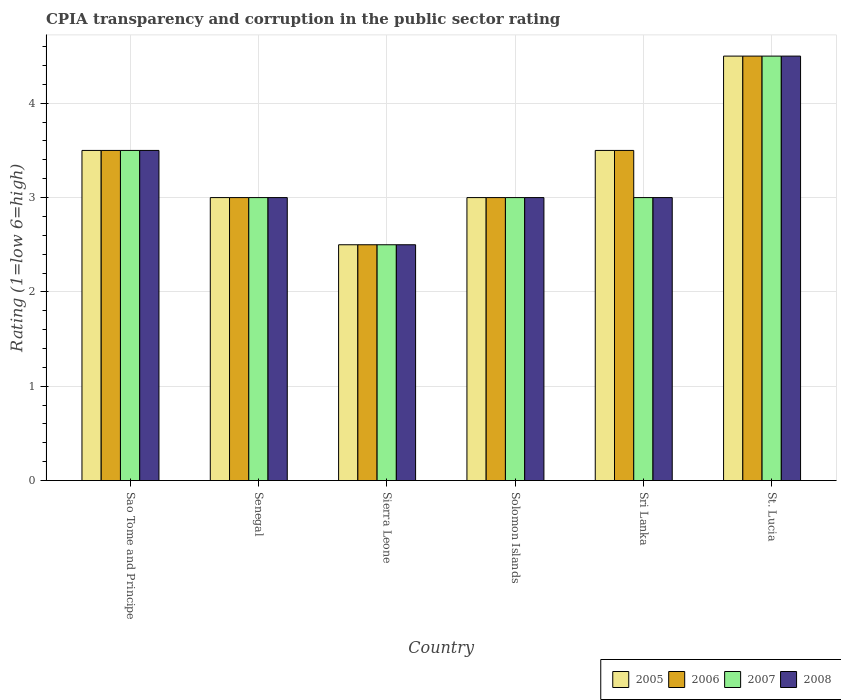How many groups of bars are there?
Offer a very short reply. 6. Are the number of bars per tick equal to the number of legend labels?
Make the answer very short. Yes. What is the label of the 3rd group of bars from the left?
Offer a very short reply. Sierra Leone. In how many cases, is the number of bars for a given country not equal to the number of legend labels?
Give a very brief answer. 0. What is the CPIA rating in 2008 in Sri Lanka?
Make the answer very short. 3. In which country was the CPIA rating in 2007 maximum?
Provide a short and direct response. St. Lucia. In which country was the CPIA rating in 2008 minimum?
Offer a terse response. Sierra Leone. What is the difference between the CPIA rating in 2007 in Sao Tome and Principe and that in St. Lucia?
Your response must be concise. -1. What is the difference between the CPIA rating in 2006 in Sierra Leone and the CPIA rating in 2008 in Solomon Islands?
Give a very brief answer. -0.5. What is the average CPIA rating in 2006 per country?
Your answer should be compact. 3.33. What is the difference between the CPIA rating of/in 2008 and CPIA rating of/in 2005 in Sao Tome and Principe?
Ensure brevity in your answer.  0. What is the ratio of the CPIA rating in 2005 in Sao Tome and Principe to that in St. Lucia?
Your answer should be very brief. 0.78. In how many countries, is the CPIA rating in 2008 greater than the average CPIA rating in 2008 taken over all countries?
Make the answer very short. 2. Is the sum of the CPIA rating in 2005 in Senegal and Sri Lanka greater than the maximum CPIA rating in 2007 across all countries?
Offer a terse response. Yes. What does the 1st bar from the left in Sao Tome and Principe represents?
Your answer should be very brief. 2005. What does the 1st bar from the right in Sierra Leone represents?
Your response must be concise. 2008. Is it the case that in every country, the sum of the CPIA rating in 2006 and CPIA rating in 2005 is greater than the CPIA rating in 2008?
Keep it short and to the point. Yes. How many bars are there?
Provide a short and direct response. 24. How many countries are there in the graph?
Make the answer very short. 6. What is the difference between two consecutive major ticks on the Y-axis?
Your answer should be very brief. 1. Are the values on the major ticks of Y-axis written in scientific E-notation?
Keep it short and to the point. No. Does the graph contain any zero values?
Ensure brevity in your answer.  No. Does the graph contain grids?
Your answer should be compact. Yes. Where does the legend appear in the graph?
Your answer should be compact. Bottom right. How many legend labels are there?
Keep it short and to the point. 4. What is the title of the graph?
Offer a terse response. CPIA transparency and corruption in the public sector rating. What is the label or title of the X-axis?
Provide a succinct answer. Country. What is the label or title of the Y-axis?
Make the answer very short. Rating (1=low 6=high). What is the Rating (1=low 6=high) in 2005 in Sao Tome and Principe?
Make the answer very short. 3.5. What is the Rating (1=low 6=high) in 2007 in Sao Tome and Principe?
Offer a terse response. 3.5. What is the Rating (1=low 6=high) of 2005 in Sierra Leone?
Offer a terse response. 2.5. What is the Rating (1=low 6=high) in 2006 in Sierra Leone?
Make the answer very short. 2.5. What is the Rating (1=low 6=high) of 2008 in Sierra Leone?
Keep it short and to the point. 2.5. What is the Rating (1=low 6=high) of 2005 in Solomon Islands?
Give a very brief answer. 3. What is the Rating (1=low 6=high) in 2006 in Solomon Islands?
Your answer should be very brief. 3. What is the Rating (1=low 6=high) of 2007 in Sri Lanka?
Your response must be concise. 3. What is the Rating (1=low 6=high) in 2005 in St. Lucia?
Keep it short and to the point. 4.5. What is the Rating (1=low 6=high) in 2006 in St. Lucia?
Give a very brief answer. 4.5. Across all countries, what is the maximum Rating (1=low 6=high) in 2005?
Offer a terse response. 4.5. Across all countries, what is the maximum Rating (1=low 6=high) of 2008?
Offer a terse response. 4.5. Across all countries, what is the minimum Rating (1=low 6=high) of 2005?
Provide a succinct answer. 2.5. Across all countries, what is the minimum Rating (1=low 6=high) in 2006?
Offer a very short reply. 2.5. Across all countries, what is the minimum Rating (1=low 6=high) in 2007?
Offer a terse response. 2.5. What is the total Rating (1=low 6=high) in 2005 in the graph?
Provide a short and direct response. 20. What is the total Rating (1=low 6=high) of 2007 in the graph?
Make the answer very short. 19.5. What is the difference between the Rating (1=low 6=high) in 2005 in Sao Tome and Principe and that in Senegal?
Ensure brevity in your answer.  0.5. What is the difference between the Rating (1=low 6=high) of 2006 in Sao Tome and Principe and that in Senegal?
Ensure brevity in your answer.  0.5. What is the difference between the Rating (1=low 6=high) in 2005 in Sao Tome and Principe and that in Sierra Leone?
Your answer should be compact. 1. What is the difference between the Rating (1=low 6=high) of 2008 in Sao Tome and Principe and that in Sierra Leone?
Offer a terse response. 1. What is the difference between the Rating (1=low 6=high) in 2005 in Sao Tome and Principe and that in Solomon Islands?
Your response must be concise. 0.5. What is the difference between the Rating (1=low 6=high) in 2006 in Sao Tome and Principe and that in Solomon Islands?
Your answer should be compact. 0.5. What is the difference between the Rating (1=low 6=high) of 2006 in Sao Tome and Principe and that in Sri Lanka?
Your answer should be very brief. 0. What is the difference between the Rating (1=low 6=high) in 2007 in Sao Tome and Principe and that in Sri Lanka?
Give a very brief answer. 0.5. What is the difference between the Rating (1=low 6=high) of 2005 in Senegal and that in Sierra Leone?
Keep it short and to the point. 0.5. What is the difference between the Rating (1=low 6=high) in 2005 in Senegal and that in Solomon Islands?
Your answer should be very brief. 0. What is the difference between the Rating (1=low 6=high) in 2006 in Senegal and that in Solomon Islands?
Your answer should be very brief. 0. What is the difference between the Rating (1=low 6=high) of 2008 in Senegal and that in Solomon Islands?
Make the answer very short. 0. What is the difference between the Rating (1=low 6=high) in 2006 in Senegal and that in Sri Lanka?
Offer a very short reply. -0.5. What is the difference between the Rating (1=low 6=high) of 2007 in Senegal and that in Sri Lanka?
Ensure brevity in your answer.  0. What is the difference between the Rating (1=low 6=high) of 2008 in Senegal and that in Sri Lanka?
Your answer should be very brief. 0. What is the difference between the Rating (1=low 6=high) in 2008 in Senegal and that in St. Lucia?
Provide a succinct answer. -1.5. What is the difference between the Rating (1=low 6=high) in 2007 in Sierra Leone and that in Solomon Islands?
Offer a terse response. -0.5. What is the difference between the Rating (1=low 6=high) of 2008 in Sierra Leone and that in Solomon Islands?
Offer a very short reply. -0.5. What is the difference between the Rating (1=low 6=high) in 2006 in Sierra Leone and that in Sri Lanka?
Your answer should be compact. -1. What is the difference between the Rating (1=low 6=high) in 2008 in Sierra Leone and that in Sri Lanka?
Offer a terse response. -0.5. What is the difference between the Rating (1=low 6=high) of 2006 in Sierra Leone and that in St. Lucia?
Your response must be concise. -2. What is the difference between the Rating (1=low 6=high) of 2006 in Solomon Islands and that in Sri Lanka?
Keep it short and to the point. -0.5. What is the difference between the Rating (1=low 6=high) in 2008 in Solomon Islands and that in Sri Lanka?
Keep it short and to the point. 0. What is the difference between the Rating (1=low 6=high) of 2005 in Solomon Islands and that in St. Lucia?
Your answer should be very brief. -1.5. What is the difference between the Rating (1=low 6=high) in 2005 in Sri Lanka and that in St. Lucia?
Provide a short and direct response. -1. What is the difference between the Rating (1=low 6=high) of 2007 in Sri Lanka and that in St. Lucia?
Keep it short and to the point. -1.5. What is the difference between the Rating (1=low 6=high) of 2008 in Sri Lanka and that in St. Lucia?
Provide a short and direct response. -1.5. What is the difference between the Rating (1=low 6=high) of 2005 in Sao Tome and Principe and the Rating (1=low 6=high) of 2006 in Senegal?
Your answer should be compact. 0.5. What is the difference between the Rating (1=low 6=high) of 2005 in Sao Tome and Principe and the Rating (1=low 6=high) of 2008 in Senegal?
Offer a terse response. 0.5. What is the difference between the Rating (1=low 6=high) of 2006 in Sao Tome and Principe and the Rating (1=low 6=high) of 2007 in Senegal?
Make the answer very short. 0.5. What is the difference between the Rating (1=low 6=high) in 2007 in Sao Tome and Principe and the Rating (1=low 6=high) in 2008 in Senegal?
Give a very brief answer. 0.5. What is the difference between the Rating (1=low 6=high) in 2006 in Sao Tome and Principe and the Rating (1=low 6=high) in 2008 in Sierra Leone?
Your response must be concise. 1. What is the difference between the Rating (1=low 6=high) in 2007 in Sao Tome and Principe and the Rating (1=low 6=high) in 2008 in Sierra Leone?
Provide a short and direct response. 1. What is the difference between the Rating (1=low 6=high) in 2005 in Sao Tome and Principe and the Rating (1=low 6=high) in 2006 in Solomon Islands?
Provide a short and direct response. 0.5. What is the difference between the Rating (1=low 6=high) of 2005 in Sao Tome and Principe and the Rating (1=low 6=high) of 2007 in Solomon Islands?
Provide a short and direct response. 0.5. What is the difference between the Rating (1=low 6=high) in 2006 in Sao Tome and Principe and the Rating (1=low 6=high) in 2007 in Solomon Islands?
Offer a terse response. 0.5. What is the difference between the Rating (1=low 6=high) in 2006 in Sao Tome and Principe and the Rating (1=low 6=high) in 2008 in Solomon Islands?
Your response must be concise. 0.5. What is the difference between the Rating (1=low 6=high) of 2005 in Sao Tome and Principe and the Rating (1=low 6=high) of 2006 in Sri Lanka?
Your answer should be compact. 0. What is the difference between the Rating (1=low 6=high) of 2005 in Sao Tome and Principe and the Rating (1=low 6=high) of 2008 in Sri Lanka?
Keep it short and to the point. 0.5. What is the difference between the Rating (1=low 6=high) of 2006 in Sao Tome and Principe and the Rating (1=low 6=high) of 2007 in Sri Lanka?
Give a very brief answer. 0.5. What is the difference between the Rating (1=low 6=high) of 2006 in Sao Tome and Principe and the Rating (1=low 6=high) of 2008 in Sri Lanka?
Make the answer very short. 0.5. What is the difference between the Rating (1=low 6=high) of 2005 in Sao Tome and Principe and the Rating (1=low 6=high) of 2006 in St. Lucia?
Provide a short and direct response. -1. What is the difference between the Rating (1=low 6=high) in 2005 in Sao Tome and Principe and the Rating (1=low 6=high) in 2007 in St. Lucia?
Your answer should be compact. -1. What is the difference between the Rating (1=low 6=high) of 2006 in Sao Tome and Principe and the Rating (1=low 6=high) of 2007 in St. Lucia?
Provide a short and direct response. -1. What is the difference between the Rating (1=low 6=high) in 2006 in Sao Tome and Principe and the Rating (1=low 6=high) in 2008 in St. Lucia?
Provide a succinct answer. -1. What is the difference between the Rating (1=low 6=high) of 2005 in Senegal and the Rating (1=low 6=high) of 2008 in Sierra Leone?
Ensure brevity in your answer.  0.5. What is the difference between the Rating (1=low 6=high) in 2006 in Senegal and the Rating (1=low 6=high) in 2008 in Sierra Leone?
Provide a succinct answer. 0.5. What is the difference between the Rating (1=low 6=high) in 2007 in Senegal and the Rating (1=low 6=high) in 2008 in Sierra Leone?
Your response must be concise. 0.5. What is the difference between the Rating (1=low 6=high) of 2005 in Senegal and the Rating (1=low 6=high) of 2006 in Solomon Islands?
Your answer should be very brief. 0. What is the difference between the Rating (1=low 6=high) in 2005 in Senegal and the Rating (1=low 6=high) in 2007 in Solomon Islands?
Provide a short and direct response. 0. What is the difference between the Rating (1=low 6=high) in 2005 in Senegal and the Rating (1=low 6=high) in 2008 in Solomon Islands?
Your answer should be compact. 0. What is the difference between the Rating (1=low 6=high) in 2005 in Senegal and the Rating (1=low 6=high) in 2006 in Sri Lanka?
Keep it short and to the point. -0.5. What is the difference between the Rating (1=low 6=high) in 2005 in Senegal and the Rating (1=low 6=high) in 2007 in Sri Lanka?
Offer a terse response. 0. What is the difference between the Rating (1=low 6=high) in 2005 in Senegal and the Rating (1=low 6=high) in 2008 in Sri Lanka?
Your response must be concise. 0. What is the difference between the Rating (1=low 6=high) of 2006 in Senegal and the Rating (1=low 6=high) of 2007 in Sri Lanka?
Provide a short and direct response. 0. What is the difference between the Rating (1=low 6=high) of 2007 in Senegal and the Rating (1=low 6=high) of 2008 in Sri Lanka?
Make the answer very short. 0. What is the difference between the Rating (1=low 6=high) in 2005 in Senegal and the Rating (1=low 6=high) in 2008 in St. Lucia?
Your answer should be compact. -1.5. What is the difference between the Rating (1=low 6=high) of 2006 in Senegal and the Rating (1=low 6=high) of 2007 in St. Lucia?
Offer a terse response. -1.5. What is the difference between the Rating (1=low 6=high) of 2006 in Senegal and the Rating (1=low 6=high) of 2008 in St. Lucia?
Your answer should be compact. -1.5. What is the difference between the Rating (1=low 6=high) in 2007 in Senegal and the Rating (1=low 6=high) in 2008 in St. Lucia?
Offer a terse response. -1.5. What is the difference between the Rating (1=low 6=high) of 2005 in Sierra Leone and the Rating (1=low 6=high) of 2006 in Solomon Islands?
Keep it short and to the point. -0.5. What is the difference between the Rating (1=low 6=high) in 2005 in Sierra Leone and the Rating (1=low 6=high) in 2008 in Solomon Islands?
Offer a terse response. -0.5. What is the difference between the Rating (1=low 6=high) in 2006 in Sierra Leone and the Rating (1=low 6=high) in 2007 in Solomon Islands?
Your answer should be very brief. -0.5. What is the difference between the Rating (1=low 6=high) in 2005 in Sierra Leone and the Rating (1=low 6=high) in 2006 in Sri Lanka?
Keep it short and to the point. -1. What is the difference between the Rating (1=low 6=high) in 2005 in Sierra Leone and the Rating (1=low 6=high) in 2008 in Sri Lanka?
Provide a short and direct response. -0.5. What is the difference between the Rating (1=low 6=high) of 2006 in Sierra Leone and the Rating (1=low 6=high) of 2007 in Sri Lanka?
Offer a terse response. -0.5. What is the difference between the Rating (1=low 6=high) of 2005 in Sierra Leone and the Rating (1=low 6=high) of 2007 in St. Lucia?
Make the answer very short. -2. What is the difference between the Rating (1=low 6=high) in 2006 in Sierra Leone and the Rating (1=low 6=high) in 2008 in St. Lucia?
Provide a succinct answer. -2. What is the difference between the Rating (1=low 6=high) in 2007 in Sierra Leone and the Rating (1=low 6=high) in 2008 in St. Lucia?
Your answer should be very brief. -2. What is the difference between the Rating (1=low 6=high) in 2005 in Solomon Islands and the Rating (1=low 6=high) in 2006 in Sri Lanka?
Make the answer very short. -0.5. What is the difference between the Rating (1=low 6=high) of 2005 in Solomon Islands and the Rating (1=low 6=high) of 2008 in Sri Lanka?
Make the answer very short. 0. What is the difference between the Rating (1=low 6=high) of 2006 in Solomon Islands and the Rating (1=low 6=high) of 2007 in Sri Lanka?
Offer a very short reply. 0. What is the difference between the Rating (1=low 6=high) in 2005 in Solomon Islands and the Rating (1=low 6=high) in 2007 in St. Lucia?
Offer a terse response. -1.5. What is the difference between the Rating (1=low 6=high) of 2005 in Solomon Islands and the Rating (1=low 6=high) of 2008 in St. Lucia?
Provide a succinct answer. -1.5. What is the difference between the Rating (1=low 6=high) in 2006 in Solomon Islands and the Rating (1=low 6=high) in 2007 in St. Lucia?
Keep it short and to the point. -1.5. What is the difference between the Rating (1=low 6=high) of 2007 in Solomon Islands and the Rating (1=low 6=high) of 2008 in St. Lucia?
Keep it short and to the point. -1.5. What is the difference between the Rating (1=low 6=high) in 2005 in Sri Lanka and the Rating (1=low 6=high) in 2006 in St. Lucia?
Keep it short and to the point. -1. What is the difference between the Rating (1=low 6=high) in 2005 in Sri Lanka and the Rating (1=low 6=high) in 2008 in St. Lucia?
Provide a short and direct response. -1. What is the difference between the Rating (1=low 6=high) in 2006 in Sri Lanka and the Rating (1=low 6=high) in 2007 in St. Lucia?
Make the answer very short. -1. What is the average Rating (1=low 6=high) of 2006 per country?
Your answer should be compact. 3.33. What is the average Rating (1=low 6=high) of 2007 per country?
Keep it short and to the point. 3.25. What is the average Rating (1=low 6=high) of 2008 per country?
Keep it short and to the point. 3.25. What is the difference between the Rating (1=low 6=high) in 2005 and Rating (1=low 6=high) in 2008 in Sao Tome and Principe?
Provide a short and direct response. 0. What is the difference between the Rating (1=low 6=high) of 2005 and Rating (1=low 6=high) of 2006 in Senegal?
Your answer should be compact. 0. What is the difference between the Rating (1=low 6=high) of 2005 and Rating (1=low 6=high) of 2007 in Senegal?
Your answer should be very brief. 0. What is the difference between the Rating (1=low 6=high) in 2007 and Rating (1=low 6=high) in 2008 in Senegal?
Your response must be concise. 0. What is the difference between the Rating (1=low 6=high) in 2007 and Rating (1=low 6=high) in 2008 in Sierra Leone?
Give a very brief answer. 0. What is the difference between the Rating (1=low 6=high) in 2005 and Rating (1=low 6=high) in 2007 in Solomon Islands?
Your response must be concise. 0. What is the difference between the Rating (1=low 6=high) of 2005 and Rating (1=low 6=high) of 2008 in Solomon Islands?
Your answer should be compact. 0. What is the difference between the Rating (1=low 6=high) of 2006 and Rating (1=low 6=high) of 2008 in Solomon Islands?
Keep it short and to the point. 0. What is the difference between the Rating (1=low 6=high) of 2007 and Rating (1=low 6=high) of 2008 in Solomon Islands?
Offer a terse response. 0. What is the difference between the Rating (1=low 6=high) in 2005 and Rating (1=low 6=high) in 2008 in Sri Lanka?
Offer a very short reply. 0.5. What is the difference between the Rating (1=low 6=high) in 2007 and Rating (1=low 6=high) in 2008 in Sri Lanka?
Provide a succinct answer. 0. What is the difference between the Rating (1=low 6=high) in 2005 and Rating (1=low 6=high) in 2006 in St. Lucia?
Make the answer very short. 0. What is the difference between the Rating (1=low 6=high) in 2005 and Rating (1=low 6=high) in 2008 in St. Lucia?
Give a very brief answer. 0. What is the difference between the Rating (1=low 6=high) in 2006 and Rating (1=low 6=high) in 2007 in St. Lucia?
Your response must be concise. 0. What is the difference between the Rating (1=low 6=high) in 2006 and Rating (1=low 6=high) in 2008 in St. Lucia?
Ensure brevity in your answer.  0. What is the ratio of the Rating (1=low 6=high) of 2005 in Sao Tome and Principe to that in Senegal?
Your answer should be very brief. 1.17. What is the ratio of the Rating (1=low 6=high) of 2006 in Sao Tome and Principe to that in Senegal?
Your answer should be very brief. 1.17. What is the ratio of the Rating (1=low 6=high) in 2007 in Sao Tome and Principe to that in Senegal?
Offer a very short reply. 1.17. What is the ratio of the Rating (1=low 6=high) of 2008 in Sao Tome and Principe to that in Senegal?
Your answer should be compact. 1.17. What is the ratio of the Rating (1=low 6=high) in 2005 in Sao Tome and Principe to that in Sierra Leone?
Your response must be concise. 1.4. What is the ratio of the Rating (1=low 6=high) in 2006 in Sao Tome and Principe to that in Sierra Leone?
Keep it short and to the point. 1.4. What is the ratio of the Rating (1=low 6=high) in 2007 in Sao Tome and Principe to that in Sierra Leone?
Offer a terse response. 1.4. What is the ratio of the Rating (1=low 6=high) in 2008 in Sao Tome and Principe to that in Sierra Leone?
Give a very brief answer. 1.4. What is the ratio of the Rating (1=low 6=high) of 2005 in Sao Tome and Principe to that in Solomon Islands?
Your answer should be compact. 1.17. What is the ratio of the Rating (1=low 6=high) in 2005 in Sao Tome and Principe to that in Sri Lanka?
Give a very brief answer. 1. What is the ratio of the Rating (1=low 6=high) in 2006 in Sao Tome and Principe to that in St. Lucia?
Your answer should be compact. 0.78. What is the ratio of the Rating (1=low 6=high) in 2007 in Sao Tome and Principe to that in St. Lucia?
Offer a very short reply. 0.78. What is the ratio of the Rating (1=low 6=high) in 2008 in Sao Tome and Principe to that in St. Lucia?
Offer a very short reply. 0.78. What is the ratio of the Rating (1=low 6=high) of 2008 in Senegal to that in Sierra Leone?
Offer a terse response. 1.2. What is the ratio of the Rating (1=low 6=high) of 2005 in Senegal to that in Solomon Islands?
Ensure brevity in your answer.  1. What is the ratio of the Rating (1=low 6=high) of 2007 in Senegal to that in Solomon Islands?
Keep it short and to the point. 1. What is the ratio of the Rating (1=low 6=high) of 2008 in Senegal to that in Sri Lanka?
Provide a succinct answer. 1. What is the ratio of the Rating (1=low 6=high) of 2006 in Senegal to that in St. Lucia?
Your answer should be very brief. 0.67. What is the ratio of the Rating (1=low 6=high) in 2005 in Sierra Leone to that in Solomon Islands?
Make the answer very short. 0.83. What is the ratio of the Rating (1=low 6=high) in 2007 in Sierra Leone to that in Solomon Islands?
Ensure brevity in your answer.  0.83. What is the ratio of the Rating (1=low 6=high) of 2005 in Sierra Leone to that in St. Lucia?
Your answer should be very brief. 0.56. What is the ratio of the Rating (1=low 6=high) in 2006 in Sierra Leone to that in St. Lucia?
Make the answer very short. 0.56. What is the ratio of the Rating (1=low 6=high) in 2007 in Sierra Leone to that in St. Lucia?
Offer a very short reply. 0.56. What is the ratio of the Rating (1=low 6=high) in 2008 in Sierra Leone to that in St. Lucia?
Make the answer very short. 0.56. What is the ratio of the Rating (1=low 6=high) in 2006 in Solomon Islands to that in Sri Lanka?
Keep it short and to the point. 0.86. What is the ratio of the Rating (1=low 6=high) of 2006 in Solomon Islands to that in St. Lucia?
Make the answer very short. 0.67. What is the ratio of the Rating (1=low 6=high) in 2006 in Sri Lanka to that in St. Lucia?
Offer a very short reply. 0.78. What is the ratio of the Rating (1=low 6=high) of 2007 in Sri Lanka to that in St. Lucia?
Keep it short and to the point. 0.67. What is the difference between the highest and the lowest Rating (1=low 6=high) of 2005?
Your answer should be compact. 2. What is the difference between the highest and the lowest Rating (1=low 6=high) of 2006?
Offer a very short reply. 2. What is the difference between the highest and the lowest Rating (1=low 6=high) in 2007?
Provide a short and direct response. 2. 